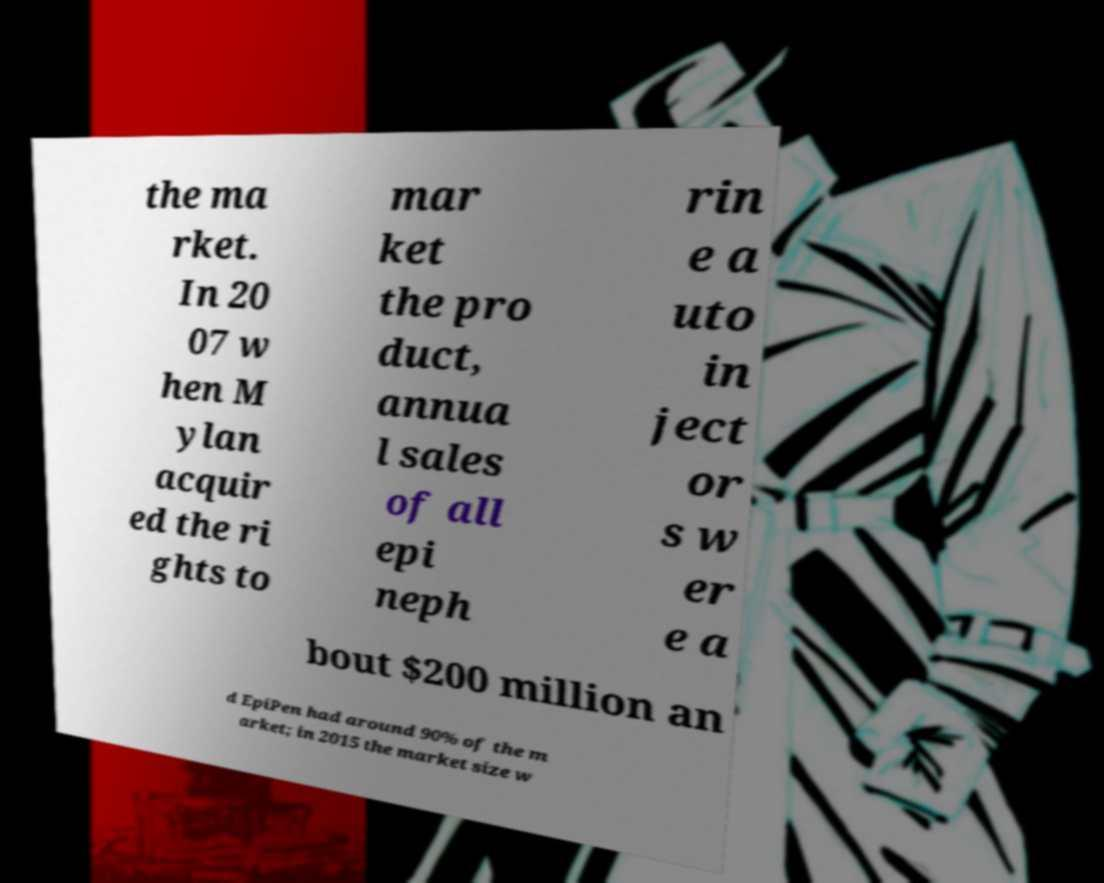Could you extract and type out the text from this image? the ma rket. In 20 07 w hen M ylan acquir ed the ri ghts to mar ket the pro duct, annua l sales of all epi neph rin e a uto in ject or s w er e a bout $200 million an d EpiPen had around 90% of the m arket; in 2015 the market size w 